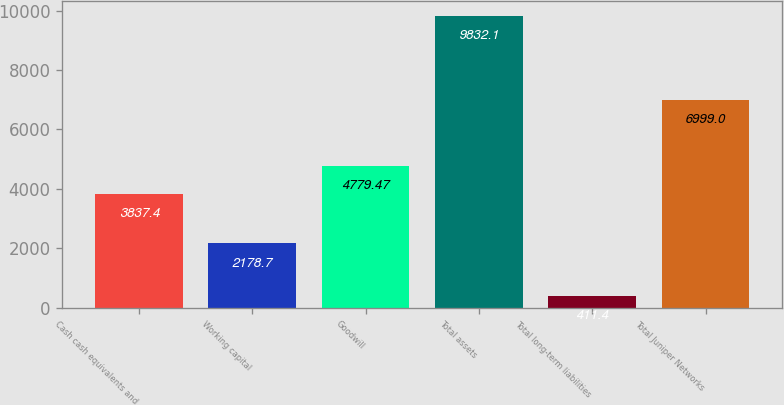Convert chart. <chart><loc_0><loc_0><loc_500><loc_500><bar_chart><fcel>Cash cash equivalents and<fcel>Working capital<fcel>Goodwill<fcel>Total assets<fcel>Total long-term liabilities<fcel>Total Juniper Networks<nl><fcel>3837.4<fcel>2178.7<fcel>4779.47<fcel>9832.1<fcel>411.4<fcel>6999<nl></chart> 